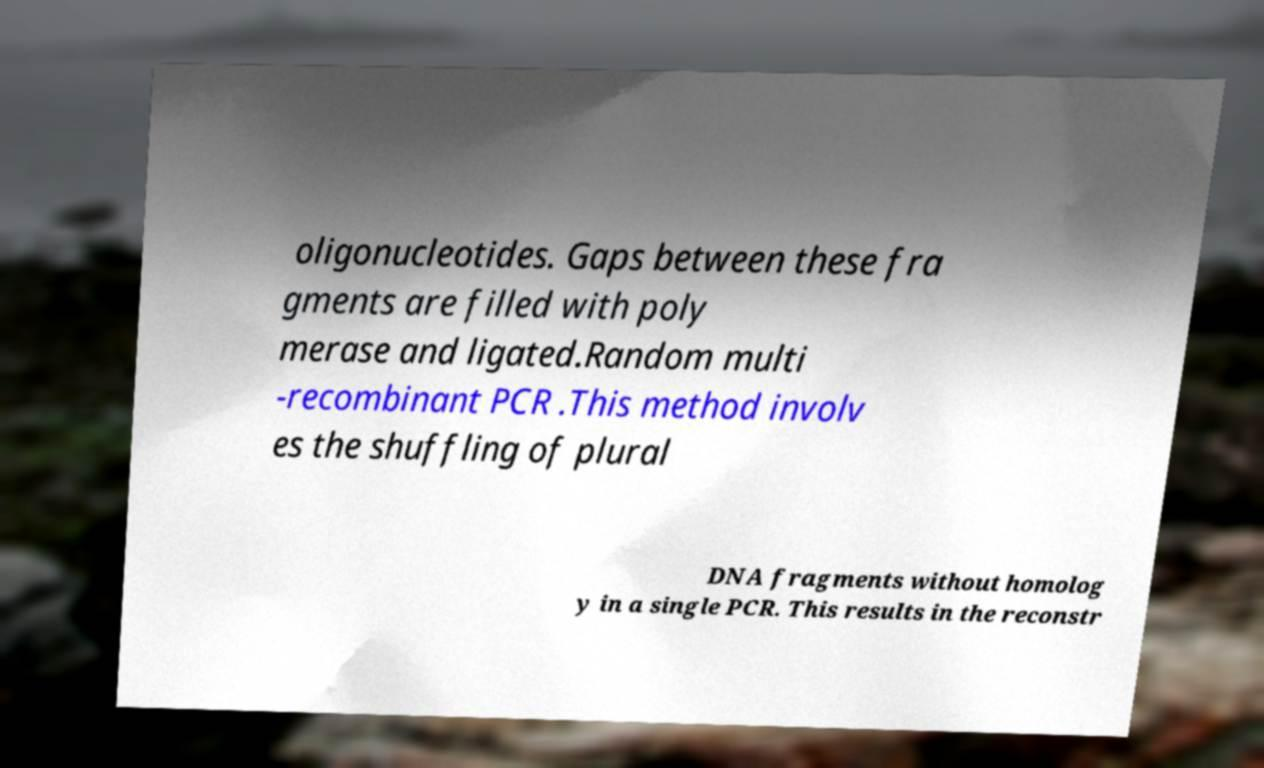Could you extract and type out the text from this image? oligonucleotides. Gaps between these fra gments are filled with poly merase and ligated.Random multi -recombinant PCR .This method involv es the shuffling of plural DNA fragments without homolog y in a single PCR. This results in the reconstr 